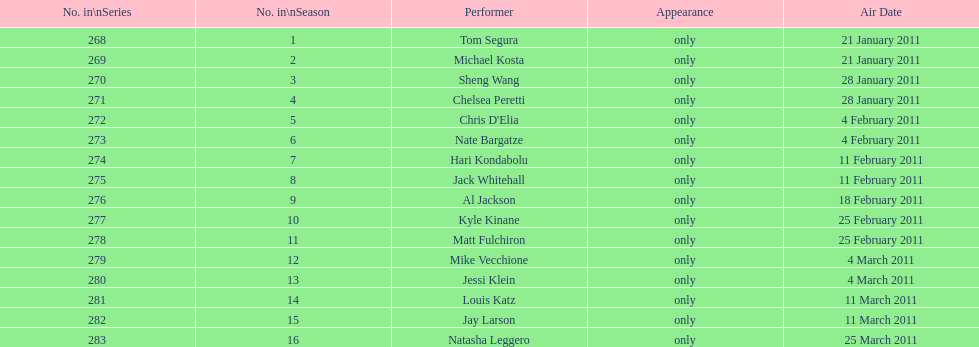What is the last name of hari? Kondabolu. 